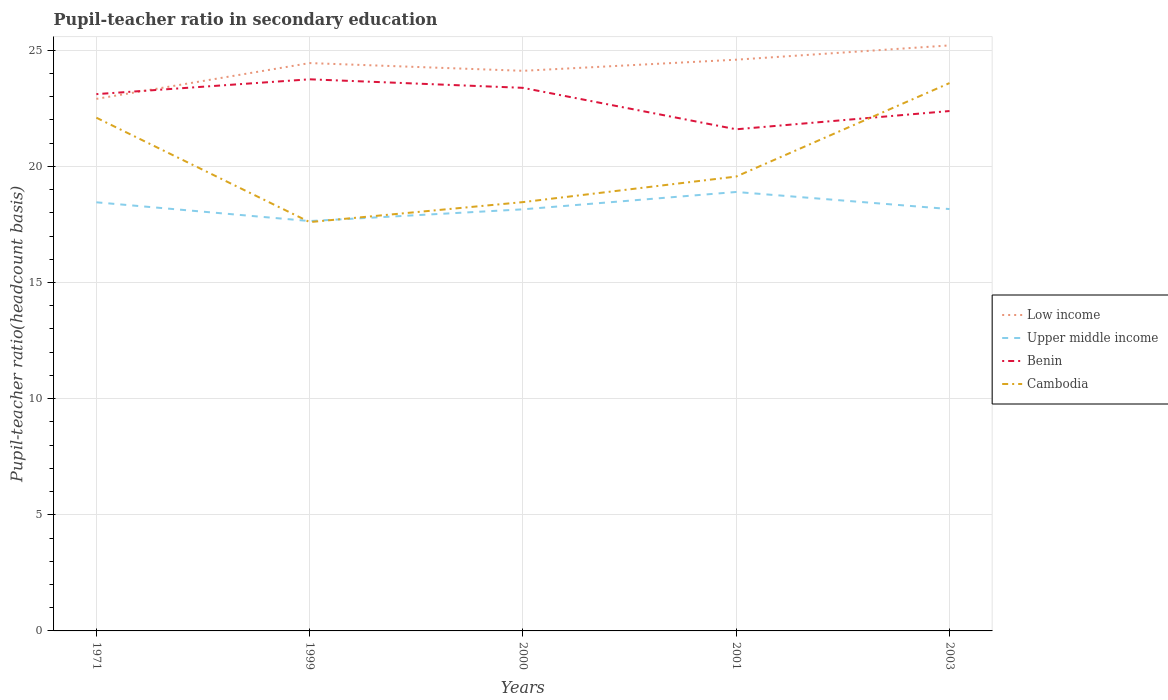How many different coloured lines are there?
Give a very brief answer. 4. Across all years, what is the maximum pupil-teacher ratio in secondary education in Upper middle income?
Provide a short and direct response. 17.65. What is the total pupil-teacher ratio in secondary education in Cambodia in the graph?
Ensure brevity in your answer.  -1.96. What is the difference between the highest and the second highest pupil-teacher ratio in secondary education in Benin?
Ensure brevity in your answer.  2.15. How many lines are there?
Your answer should be compact. 4. How many years are there in the graph?
Your answer should be compact. 5. Are the values on the major ticks of Y-axis written in scientific E-notation?
Offer a very short reply. No. Where does the legend appear in the graph?
Give a very brief answer. Center right. How many legend labels are there?
Keep it short and to the point. 4. How are the legend labels stacked?
Provide a short and direct response. Vertical. What is the title of the graph?
Make the answer very short. Pupil-teacher ratio in secondary education. What is the label or title of the X-axis?
Provide a succinct answer. Years. What is the label or title of the Y-axis?
Ensure brevity in your answer.  Pupil-teacher ratio(headcount basis). What is the Pupil-teacher ratio(headcount basis) in Low income in 1971?
Offer a terse response. 22.91. What is the Pupil-teacher ratio(headcount basis) of Upper middle income in 1971?
Offer a very short reply. 18.46. What is the Pupil-teacher ratio(headcount basis) of Benin in 1971?
Offer a terse response. 23.11. What is the Pupil-teacher ratio(headcount basis) of Cambodia in 1971?
Offer a very short reply. 22.1. What is the Pupil-teacher ratio(headcount basis) of Low income in 1999?
Ensure brevity in your answer.  24.45. What is the Pupil-teacher ratio(headcount basis) of Upper middle income in 1999?
Provide a short and direct response. 17.65. What is the Pupil-teacher ratio(headcount basis) in Benin in 1999?
Your answer should be compact. 23.75. What is the Pupil-teacher ratio(headcount basis) in Cambodia in 1999?
Ensure brevity in your answer.  17.6. What is the Pupil-teacher ratio(headcount basis) of Low income in 2000?
Your response must be concise. 24.12. What is the Pupil-teacher ratio(headcount basis) of Upper middle income in 2000?
Keep it short and to the point. 18.15. What is the Pupil-teacher ratio(headcount basis) in Benin in 2000?
Your response must be concise. 23.38. What is the Pupil-teacher ratio(headcount basis) of Cambodia in 2000?
Offer a terse response. 18.46. What is the Pupil-teacher ratio(headcount basis) of Low income in 2001?
Provide a succinct answer. 24.6. What is the Pupil-teacher ratio(headcount basis) of Upper middle income in 2001?
Offer a terse response. 18.9. What is the Pupil-teacher ratio(headcount basis) of Benin in 2001?
Give a very brief answer. 21.6. What is the Pupil-teacher ratio(headcount basis) in Cambodia in 2001?
Your response must be concise. 19.56. What is the Pupil-teacher ratio(headcount basis) in Low income in 2003?
Offer a terse response. 25.21. What is the Pupil-teacher ratio(headcount basis) in Upper middle income in 2003?
Give a very brief answer. 18.16. What is the Pupil-teacher ratio(headcount basis) in Benin in 2003?
Provide a short and direct response. 22.38. What is the Pupil-teacher ratio(headcount basis) of Cambodia in 2003?
Offer a terse response. 23.59. Across all years, what is the maximum Pupil-teacher ratio(headcount basis) in Low income?
Provide a succinct answer. 25.21. Across all years, what is the maximum Pupil-teacher ratio(headcount basis) in Upper middle income?
Your answer should be very brief. 18.9. Across all years, what is the maximum Pupil-teacher ratio(headcount basis) in Benin?
Offer a very short reply. 23.75. Across all years, what is the maximum Pupil-teacher ratio(headcount basis) in Cambodia?
Keep it short and to the point. 23.59. Across all years, what is the minimum Pupil-teacher ratio(headcount basis) of Low income?
Keep it short and to the point. 22.91. Across all years, what is the minimum Pupil-teacher ratio(headcount basis) in Upper middle income?
Your response must be concise. 17.65. Across all years, what is the minimum Pupil-teacher ratio(headcount basis) of Benin?
Ensure brevity in your answer.  21.6. Across all years, what is the minimum Pupil-teacher ratio(headcount basis) of Cambodia?
Ensure brevity in your answer.  17.6. What is the total Pupil-teacher ratio(headcount basis) in Low income in the graph?
Offer a terse response. 121.28. What is the total Pupil-teacher ratio(headcount basis) in Upper middle income in the graph?
Your answer should be very brief. 91.32. What is the total Pupil-teacher ratio(headcount basis) of Benin in the graph?
Provide a succinct answer. 114.23. What is the total Pupil-teacher ratio(headcount basis) in Cambodia in the graph?
Provide a succinct answer. 101.32. What is the difference between the Pupil-teacher ratio(headcount basis) of Low income in 1971 and that in 1999?
Give a very brief answer. -1.54. What is the difference between the Pupil-teacher ratio(headcount basis) of Upper middle income in 1971 and that in 1999?
Make the answer very short. 0.81. What is the difference between the Pupil-teacher ratio(headcount basis) in Benin in 1971 and that in 1999?
Your response must be concise. -0.64. What is the difference between the Pupil-teacher ratio(headcount basis) in Cambodia in 1971 and that in 1999?
Make the answer very short. 4.49. What is the difference between the Pupil-teacher ratio(headcount basis) in Low income in 1971 and that in 2000?
Give a very brief answer. -1.21. What is the difference between the Pupil-teacher ratio(headcount basis) in Upper middle income in 1971 and that in 2000?
Your response must be concise. 0.3. What is the difference between the Pupil-teacher ratio(headcount basis) in Benin in 1971 and that in 2000?
Make the answer very short. -0.27. What is the difference between the Pupil-teacher ratio(headcount basis) in Cambodia in 1971 and that in 2000?
Your answer should be compact. 3.63. What is the difference between the Pupil-teacher ratio(headcount basis) in Low income in 1971 and that in 2001?
Ensure brevity in your answer.  -1.69. What is the difference between the Pupil-teacher ratio(headcount basis) of Upper middle income in 1971 and that in 2001?
Provide a short and direct response. -0.44. What is the difference between the Pupil-teacher ratio(headcount basis) in Benin in 1971 and that in 2001?
Give a very brief answer. 1.51. What is the difference between the Pupil-teacher ratio(headcount basis) of Cambodia in 1971 and that in 2001?
Your answer should be very brief. 2.53. What is the difference between the Pupil-teacher ratio(headcount basis) of Low income in 1971 and that in 2003?
Keep it short and to the point. -2.3. What is the difference between the Pupil-teacher ratio(headcount basis) of Upper middle income in 1971 and that in 2003?
Ensure brevity in your answer.  0.29. What is the difference between the Pupil-teacher ratio(headcount basis) of Benin in 1971 and that in 2003?
Your response must be concise. 0.73. What is the difference between the Pupil-teacher ratio(headcount basis) of Cambodia in 1971 and that in 2003?
Make the answer very short. -1.49. What is the difference between the Pupil-teacher ratio(headcount basis) of Low income in 1999 and that in 2000?
Your answer should be very brief. 0.33. What is the difference between the Pupil-teacher ratio(headcount basis) in Upper middle income in 1999 and that in 2000?
Offer a very short reply. -0.51. What is the difference between the Pupil-teacher ratio(headcount basis) in Benin in 1999 and that in 2000?
Give a very brief answer. 0.37. What is the difference between the Pupil-teacher ratio(headcount basis) in Cambodia in 1999 and that in 2000?
Your response must be concise. -0.86. What is the difference between the Pupil-teacher ratio(headcount basis) of Low income in 1999 and that in 2001?
Your response must be concise. -0.15. What is the difference between the Pupil-teacher ratio(headcount basis) of Upper middle income in 1999 and that in 2001?
Make the answer very short. -1.25. What is the difference between the Pupil-teacher ratio(headcount basis) in Benin in 1999 and that in 2001?
Your response must be concise. 2.15. What is the difference between the Pupil-teacher ratio(headcount basis) of Cambodia in 1999 and that in 2001?
Offer a very short reply. -1.96. What is the difference between the Pupil-teacher ratio(headcount basis) in Low income in 1999 and that in 2003?
Your response must be concise. -0.76. What is the difference between the Pupil-teacher ratio(headcount basis) in Upper middle income in 1999 and that in 2003?
Ensure brevity in your answer.  -0.52. What is the difference between the Pupil-teacher ratio(headcount basis) in Benin in 1999 and that in 2003?
Ensure brevity in your answer.  1.37. What is the difference between the Pupil-teacher ratio(headcount basis) in Cambodia in 1999 and that in 2003?
Ensure brevity in your answer.  -5.99. What is the difference between the Pupil-teacher ratio(headcount basis) of Low income in 2000 and that in 2001?
Ensure brevity in your answer.  -0.48. What is the difference between the Pupil-teacher ratio(headcount basis) of Upper middle income in 2000 and that in 2001?
Make the answer very short. -0.75. What is the difference between the Pupil-teacher ratio(headcount basis) in Benin in 2000 and that in 2001?
Your answer should be compact. 1.78. What is the difference between the Pupil-teacher ratio(headcount basis) in Cambodia in 2000 and that in 2001?
Provide a succinct answer. -1.1. What is the difference between the Pupil-teacher ratio(headcount basis) in Low income in 2000 and that in 2003?
Offer a very short reply. -1.09. What is the difference between the Pupil-teacher ratio(headcount basis) of Upper middle income in 2000 and that in 2003?
Provide a succinct answer. -0.01. What is the difference between the Pupil-teacher ratio(headcount basis) of Cambodia in 2000 and that in 2003?
Keep it short and to the point. -5.12. What is the difference between the Pupil-teacher ratio(headcount basis) of Low income in 2001 and that in 2003?
Offer a very short reply. -0.61. What is the difference between the Pupil-teacher ratio(headcount basis) in Upper middle income in 2001 and that in 2003?
Your response must be concise. 0.74. What is the difference between the Pupil-teacher ratio(headcount basis) of Benin in 2001 and that in 2003?
Your response must be concise. -0.79. What is the difference between the Pupil-teacher ratio(headcount basis) of Cambodia in 2001 and that in 2003?
Give a very brief answer. -4.02. What is the difference between the Pupil-teacher ratio(headcount basis) in Low income in 1971 and the Pupil-teacher ratio(headcount basis) in Upper middle income in 1999?
Make the answer very short. 5.26. What is the difference between the Pupil-teacher ratio(headcount basis) of Low income in 1971 and the Pupil-teacher ratio(headcount basis) of Benin in 1999?
Provide a succinct answer. -0.84. What is the difference between the Pupil-teacher ratio(headcount basis) of Low income in 1971 and the Pupil-teacher ratio(headcount basis) of Cambodia in 1999?
Ensure brevity in your answer.  5.31. What is the difference between the Pupil-teacher ratio(headcount basis) of Upper middle income in 1971 and the Pupil-teacher ratio(headcount basis) of Benin in 1999?
Offer a very short reply. -5.3. What is the difference between the Pupil-teacher ratio(headcount basis) in Upper middle income in 1971 and the Pupil-teacher ratio(headcount basis) in Cambodia in 1999?
Ensure brevity in your answer.  0.85. What is the difference between the Pupil-teacher ratio(headcount basis) of Benin in 1971 and the Pupil-teacher ratio(headcount basis) of Cambodia in 1999?
Offer a very short reply. 5.51. What is the difference between the Pupil-teacher ratio(headcount basis) of Low income in 1971 and the Pupil-teacher ratio(headcount basis) of Upper middle income in 2000?
Offer a terse response. 4.76. What is the difference between the Pupil-teacher ratio(headcount basis) in Low income in 1971 and the Pupil-teacher ratio(headcount basis) in Benin in 2000?
Offer a very short reply. -0.47. What is the difference between the Pupil-teacher ratio(headcount basis) of Low income in 1971 and the Pupil-teacher ratio(headcount basis) of Cambodia in 2000?
Your response must be concise. 4.45. What is the difference between the Pupil-teacher ratio(headcount basis) in Upper middle income in 1971 and the Pupil-teacher ratio(headcount basis) in Benin in 2000?
Your response must be concise. -4.93. What is the difference between the Pupil-teacher ratio(headcount basis) of Upper middle income in 1971 and the Pupil-teacher ratio(headcount basis) of Cambodia in 2000?
Your response must be concise. -0.01. What is the difference between the Pupil-teacher ratio(headcount basis) of Benin in 1971 and the Pupil-teacher ratio(headcount basis) of Cambodia in 2000?
Keep it short and to the point. 4.65. What is the difference between the Pupil-teacher ratio(headcount basis) in Low income in 1971 and the Pupil-teacher ratio(headcount basis) in Upper middle income in 2001?
Your answer should be compact. 4.01. What is the difference between the Pupil-teacher ratio(headcount basis) in Low income in 1971 and the Pupil-teacher ratio(headcount basis) in Benin in 2001?
Your answer should be very brief. 1.31. What is the difference between the Pupil-teacher ratio(headcount basis) in Low income in 1971 and the Pupil-teacher ratio(headcount basis) in Cambodia in 2001?
Provide a short and direct response. 3.34. What is the difference between the Pupil-teacher ratio(headcount basis) in Upper middle income in 1971 and the Pupil-teacher ratio(headcount basis) in Benin in 2001?
Your response must be concise. -3.14. What is the difference between the Pupil-teacher ratio(headcount basis) of Upper middle income in 1971 and the Pupil-teacher ratio(headcount basis) of Cambodia in 2001?
Give a very brief answer. -1.11. What is the difference between the Pupil-teacher ratio(headcount basis) in Benin in 1971 and the Pupil-teacher ratio(headcount basis) in Cambodia in 2001?
Provide a short and direct response. 3.55. What is the difference between the Pupil-teacher ratio(headcount basis) in Low income in 1971 and the Pupil-teacher ratio(headcount basis) in Upper middle income in 2003?
Offer a terse response. 4.74. What is the difference between the Pupil-teacher ratio(headcount basis) in Low income in 1971 and the Pupil-teacher ratio(headcount basis) in Benin in 2003?
Give a very brief answer. 0.52. What is the difference between the Pupil-teacher ratio(headcount basis) of Low income in 1971 and the Pupil-teacher ratio(headcount basis) of Cambodia in 2003?
Offer a very short reply. -0.68. What is the difference between the Pupil-teacher ratio(headcount basis) of Upper middle income in 1971 and the Pupil-teacher ratio(headcount basis) of Benin in 2003?
Provide a short and direct response. -3.93. What is the difference between the Pupil-teacher ratio(headcount basis) in Upper middle income in 1971 and the Pupil-teacher ratio(headcount basis) in Cambodia in 2003?
Offer a terse response. -5.13. What is the difference between the Pupil-teacher ratio(headcount basis) of Benin in 1971 and the Pupil-teacher ratio(headcount basis) of Cambodia in 2003?
Offer a very short reply. -0.48. What is the difference between the Pupil-teacher ratio(headcount basis) in Low income in 1999 and the Pupil-teacher ratio(headcount basis) in Upper middle income in 2000?
Your answer should be very brief. 6.3. What is the difference between the Pupil-teacher ratio(headcount basis) of Low income in 1999 and the Pupil-teacher ratio(headcount basis) of Benin in 2000?
Give a very brief answer. 1.07. What is the difference between the Pupil-teacher ratio(headcount basis) in Low income in 1999 and the Pupil-teacher ratio(headcount basis) in Cambodia in 2000?
Your answer should be very brief. 5.99. What is the difference between the Pupil-teacher ratio(headcount basis) of Upper middle income in 1999 and the Pupil-teacher ratio(headcount basis) of Benin in 2000?
Offer a terse response. -5.74. What is the difference between the Pupil-teacher ratio(headcount basis) in Upper middle income in 1999 and the Pupil-teacher ratio(headcount basis) in Cambodia in 2000?
Provide a succinct answer. -0.82. What is the difference between the Pupil-teacher ratio(headcount basis) in Benin in 1999 and the Pupil-teacher ratio(headcount basis) in Cambodia in 2000?
Ensure brevity in your answer.  5.29. What is the difference between the Pupil-teacher ratio(headcount basis) of Low income in 1999 and the Pupil-teacher ratio(headcount basis) of Upper middle income in 2001?
Give a very brief answer. 5.55. What is the difference between the Pupil-teacher ratio(headcount basis) in Low income in 1999 and the Pupil-teacher ratio(headcount basis) in Benin in 2001?
Offer a very short reply. 2.85. What is the difference between the Pupil-teacher ratio(headcount basis) of Low income in 1999 and the Pupil-teacher ratio(headcount basis) of Cambodia in 2001?
Offer a very short reply. 4.89. What is the difference between the Pupil-teacher ratio(headcount basis) of Upper middle income in 1999 and the Pupil-teacher ratio(headcount basis) of Benin in 2001?
Offer a terse response. -3.95. What is the difference between the Pupil-teacher ratio(headcount basis) in Upper middle income in 1999 and the Pupil-teacher ratio(headcount basis) in Cambodia in 2001?
Offer a very short reply. -1.92. What is the difference between the Pupil-teacher ratio(headcount basis) of Benin in 1999 and the Pupil-teacher ratio(headcount basis) of Cambodia in 2001?
Keep it short and to the point. 4.19. What is the difference between the Pupil-teacher ratio(headcount basis) in Low income in 1999 and the Pupil-teacher ratio(headcount basis) in Upper middle income in 2003?
Your answer should be very brief. 6.29. What is the difference between the Pupil-teacher ratio(headcount basis) of Low income in 1999 and the Pupil-teacher ratio(headcount basis) of Benin in 2003?
Keep it short and to the point. 2.06. What is the difference between the Pupil-teacher ratio(headcount basis) of Low income in 1999 and the Pupil-teacher ratio(headcount basis) of Cambodia in 2003?
Give a very brief answer. 0.86. What is the difference between the Pupil-teacher ratio(headcount basis) of Upper middle income in 1999 and the Pupil-teacher ratio(headcount basis) of Benin in 2003?
Your answer should be compact. -4.74. What is the difference between the Pupil-teacher ratio(headcount basis) of Upper middle income in 1999 and the Pupil-teacher ratio(headcount basis) of Cambodia in 2003?
Provide a succinct answer. -5.94. What is the difference between the Pupil-teacher ratio(headcount basis) of Benin in 1999 and the Pupil-teacher ratio(headcount basis) of Cambodia in 2003?
Make the answer very short. 0.16. What is the difference between the Pupil-teacher ratio(headcount basis) of Low income in 2000 and the Pupil-teacher ratio(headcount basis) of Upper middle income in 2001?
Provide a short and direct response. 5.22. What is the difference between the Pupil-teacher ratio(headcount basis) of Low income in 2000 and the Pupil-teacher ratio(headcount basis) of Benin in 2001?
Provide a short and direct response. 2.52. What is the difference between the Pupil-teacher ratio(headcount basis) in Low income in 2000 and the Pupil-teacher ratio(headcount basis) in Cambodia in 2001?
Your answer should be compact. 4.55. What is the difference between the Pupil-teacher ratio(headcount basis) of Upper middle income in 2000 and the Pupil-teacher ratio(headcount basis) of Benin in 2001?
Give a very brief answer. -3.45. What is the difference between the Pupil-teacher ratio(headcount basis) in Upper middle income in 2000 and the Pupil-teacher ratio(headcount basis) in Cambodia in 2001?
Provide a short and direct response. -1.41. What is the difference between the Pupil-teacher ratio(headcount basis) of Benin in 2000 and the Pupil-teacher ratio(headcount basis) of Cambodia in 2001?
Your answer should be compact. 3.82. What is the difference between the Pupil-teacher ratio(headcount basis) of Low income in 2000 and the Pupil-teacher ratio(headcount basis) of Upper middle income in 2003?
Ensure brevity in your answer.  5.95. What is the difference between the Pupil-teacher ratio(headcount basis) of Low income in 2000 and the Pupil-teacher ratio(headcount basis) of Benin in 2003?
Your answer should be compact. 1.73. What is the difference between the Pupil-teacher ratio(headcount basis) of Low income in 2000 and the Pupil-teacher ratio(headcount basis) of Cambodia in 2003?
Ensure brevity in your answer.  0.53. What is the difference between the Pupil-teacher ratio(headcount basis) in Upper middle income in 2000 and the Pupil-teacher ratio(headcount basis) in Benin in 2003?
Give a very brief answer. -4.23. What is the difference between the Pupil-teacher ratio(headcount basis) in Upper middle income in 2000 and the Pupil-teacher ratio(headcount basis) in Cambodia in 2003?
Your answer should be very brief. -5.44. What is the difference between the Pupil-teacher ratio(headcount basis) of Benin in 2000 and the Pupil-teacher ratio(headcount basis) of Cambodia in 2003?
Ensure brevity in your answer.  -0.2. What is the difference between the Pupil-teacher ratio(headcount basis) of Low income in 2001 and the Pupil-teacher ratio(headcount basis) of Upper middle income in 2003?
Provide a succinct answer. 6.43. What is the difference between the Pupil-teacher ratio(headcount basis) of Low income in 2001 and the Pupil-teacher ratio(headcount basis) of Benin in 2003?
Make the answer very short. 2.21. What is the difference between the Pupil-teacher ratio(headcount basis) in Low income in 2001 and the Pupil-teacher ratio(headcount basis) in Cambodia in 2003?
Your answer should be compact. 1.01. What is the difference between the Pupil-teacher ratio(headcount basis) in Upper middle income in 2001 and the Pupil-teacher ratio(headcount basis) in Benin in 2003?
Your answer should be compact. -3.49. What is the difference between the Pupil-teacher ratio(headcount basis) of Upper middle income in 2001 and the Pupil-teacher ratio(headcount basis) of Cambodia in 2003?
Keep it short and to the point. -4.69. What is the difference between the Pupil-teacher ratio(headcount basis) in Benin in 2001 and the Pupil-teacher ratio(headcount basis) in Cambodia in 2003?
Provide a succinct answer. -1.99. What is the average Pupil-teacher ratio(headcount basis) of Low income per year?
Keep it short and to the point. 24.26. What is the average Pupil-teacher ratio(headcount basis) in Upper middle income per year?
Ensure brevity in your answer.  18.26. What is the average Pupil-teacher ratio(headcount basis) of Benin per year?
Your response must be concise. 22.85. What is the average Pupil-teacher ratio(headcount basis) of Cambodia per year?
Your answer should be compact. 20.26. In the year 1971, what is the difference between the Pupil-teacher ratio(headcount basis) of Low income and Pupil-teacher ratio(headcount basis) of Upper middle income?
Ensure brevity in your answer.  4.45. In the year 1971, what is the difference between the Pupil-teacher ratio(headcount basis) in Low income and Pupil-teacher ratio(headcount basis) in Benin?
Provide a short and direct response. -0.2. In the year 1971, what is the difference between the Pupil-teacher ratio(headcount basis) of Low income and Pupil-teacher ratio(headcount basis) of Cambodia?
Make the answer very short. 0.81. In the year 1971, what is the difference between the Pupil-teacher ratio(headcount basis) in Upper middle income and Pupil-teacher ratio(headcount basis) in Benin?
Your answer should be compact. -4.66. In the year 1971, what is the difference between the Pupil-teacher ratio(headcount basis) in Upper middle income and Pupil-teacher ratio(headcount basis) in Cambodia?
Your answer should be compact. -3.64. In the year 1971, what is the difference between the Pupil-teacher ratio(headcount basis) of Benin and Pupil-teacher ratio(headcount basis) of Cambodia?
Your answer should be compact. 1.01. In the year 1999, what is the difference between the Pupil-teacher ratio(headcount basis) in Low income and Pupil-teacher ratio(headcount basis) in Upper middle income?
Your answer should be very brief. 6.8. In the year 1999, what is the difference between the Pupil-teacher ratio(headcount basis) of Low income and Pupil-teacher ratio(headcount basis) of Benin?
Offer a very short reply. 0.7. In the year 1999, what is the difference between the Pupil-teacher ratio(headcount basis) in Low income and Pupil-teacher ratio(headcount basis) in Cambodia?
Ensure brevity in your answer.  6.85. In the year 1999, what is the difference between the Pupil-teacher ratio(headcount basis) of Upper middle income and Pupil-teacher ratio(headcount basis) of Benin?
Keep it short and to the point. -6.1. In the year 1999, what is the difference between the Pupil-teacher ratio(headcount basis) in Upper middle income and Pupil-teacher ratio(headcount basis) in Cambodia?
Keep it short and to the point. 0.04. In the year 1999, what is the difference between the Pupil-teacher ratio(headcount basis) in Benin and Pupil-teacher ratio(headcount basis) in Cambodia?
Offer a very short reply. 6.15. In the year 2000, what is the difference between the Pupil-teacher ratio(headcount basis) in Low income and Pupil-teacher ratio(headcount basis) in Upper middle income?
Give a very brief answer. 5.96. In the year 2000, what is the difference between the Pupil-teacher ratio(headcount basis) in Low income and Pupil-teacher ratio(headcount basis) in Benin?
Make the answer very short. 0.73. In the year 2000, what is the difference between the Pupil-teacher ratio(headcount basis) of Low income and Pupil-teacher ratio(headcount basis) of Cambodia?
Make the answer very short. 5.65. In the year 2000, what is the difference between the Pupil-teacher ratio(headcount basis) in Upper middle income and Pupil-teacher ratio(headcount basis) in Benin?
Your response must be concise. -5.23. In the year 2000, what is the difference between the Pupil-teacher ratio(headcount basis) of Upper middle income and Pupil-teacher ratio(headcount basis) of Cambodia?
Your answer should be very brief. -0.31. In the year 2000, what is the difference between the Pupil-teacher ratio(headcount basis) in Benin and Pupil-teacher ratio(headcount basis) in Cambodia?
Offer a terse response. 4.92. In the year 2001, what is the difference between the Pupil-teacher ratio(headcount basis) in Low income and Pupil-teacher ratio(headcount basis) in Upper middle income?
Keep it short and to the point. 5.7. In the year 2001, what is the difference between the Pupil-teacher ratio(headcount basis) in Low income and Pupil-teacher ratio(headcount basis) in Benin?
Offer a very short reply. 3. In the year 2001, what is the difference between the Pupil-teacher ratio(headcount basis) of Low income and Pupil-teacher ratio(headcount basis) of Cambodia?
Keep it short and to the point. 5.03. In the year 2001, what is the difference between the Pupil-teacher ratio(headcount basis) of Upper middle income and Pupil-teacher ratio(headcount basis) of Benin?
Your answer should be compact. -2.7. In the year 2001, what is the difference between the Pupil-teacher ratio(headcount basis) in Upper middle income and Pupil-teacher ratio(headcount basis) in Cambodia?
Ensure brevity in your answer.  -0.66. In the year 2001, what is the difference between the Pupil-teacher ratio(headcount basis) of Benin and Pupil-teacher ratio(headcount basis) of Cambodia?
Your answer should be very brief. 2.03. In the year 2003, what is the difference between the Pupil-teacher ratio(headcount basis) in Low income and Pupil-teacher ratio(headcount basis) in Upper middle income?
Keep it short and to the point. 7.05. In the year 2003, what is the difference between the Pupil-teacher ratio(headcount basis) of Low income and Pupil-teacher ratio(headcount basis) of Benin?
Make the answer very short. 2.83. In the year 2003, what is the difference between the Pupil-teacher ratio(headcount basis) of Low income and Pupil-teacher ratio(headcount basis) of Cambodia?
Provide a short and direct response. 1.62. In the year 2003, what is the difference between the Pupil-teacher ratio(headcount basis) of Upper middle income and Pupil-teacher ratio(headcount basis) of Benin?
Provide a succinct answer. -4.22. In the year 2003, what is the difference between the Pupil-teacher ratio(headcount basis) of Upper middle income and Pupil-teacher ratio(headcount basis) of Cambodia?
Offer a very short reply. -5.42. In the year 2003, what is the difference between the Pupil-teacher ratio(headcount basis) of Benin and Pupil-teacher ratio(headcount basis) of Cambodia?
Ensure brevity in your answer.  -1.2. What is the ratio of the Pupil-teacher ratio(headcount basis) of Low income in 1971 to that in 1999?
Your response must be concise. 0.94. What is the ratio of the Pupil-teacher ratio(headcount basis) of Upper middle income in 1971 to that in 1999?
Ensure brevity in your answer.  1.05. What is the ratio of the Pupil-teacher ratio(headcount basis) of Benin in 1971 to that in 1999?
Your answer should be compact. 0.97. What is the ratio of the Pupil-teacher ratio(headcount basis) of Cambodia in 1971 to that in 1999?
Your answer should be very brief. 1.26. What is the ratio of the Pupil-teacher ratio(headcount basis) in Low income in 1971 to that in 2000?
Your response must be concise. 0.95. What is the ratio of the Pupil-teacher ratio(headcount basis) of Upper middle income in 1971 to that in 2000?
Your response must be concise. 1.02. What is the ratio of the Pupil-teacher ratio(headcount basis) of Benin in 1971 to that in 2000?
Provide a succinct answer. 0.99. What is the ratio of the Pupil-teacher ratio(headcount basis) of Cambodia in 1971 to that in 2000?
Offer a terse response. 1.2. What is the ratio of the Pupil-teacher ratio(headcount basis) in Low income in 1971 to that in 2001?
Give a very brief answer. 0.93. What is the ratio of the Pupil-teacher ratio(headcount basis) of Upper middle income in 1971 to that in 2001?
Provide a succinct answer. 0.98. What is the ratio of the Pupil-teacher ratio(headcount basis) of Benin in 1971 to that in 2001?
Offer a terse response. 1.07. What is the ratio of the Pupil-teacher ratio(headcount basis) in Cambodia in 1971 to that in 2001?
Offer a very short reply. 1.13. What is the ratio of the Pupil-teacher ratio(headcount basis) of Low income in 1971 to that in 2003?
Ensure brevity in your answer.  0.91. What is the ratio of the Pupil-teacher ratio(headcount basis) of Upper middle income in 1971 to that in 2003?
Offer a terse response. 1.02. What is the ratio of the Pupil-teacher ratio(headcount basis) of Benin in 1971 to that in 2003?
Make the answer very short. 1.03. What is the ratio of the Pupil-teacher ratio(headcount basis) in Cambodia in 1971 to that in 2003?
Keep it short and to the point. 0.94. What is the ratio of the Pupil-teacher ratio(headcount basis) of Low income in 1999 to that in 2000?
Your answer should be compact. 1.01. What is the ratio of the Pupil-teacher ratio(headcount basis) in Upper middle income in 1999 to that in 2000?
Provide a succinct answer. 0.97. What is the ratio of the Pupil-teacher ratio(headcount basis) of Benin in 1999 to that in 2000?
Offer a very short reply. 1.02. What is the ratio of the Pupil-teacher ratio(headcount basis) in Cambodia in 1999 to that in 2000?
Ensure brevity in your answer.  0.95. What is the ratio of the Pupil-teacher ratio(headcount basis) of Low income in 1999 to that in 2001?
Make the answer very short. 0.99. What is the ratio of the Pupil-teacher ratio(headcount basis) of Upper middle income in 1999 to that in 2001?
Offer a terse response. 0.93. What is the ratio of the Pupil-teacher ratio(headcount basis) in Benin in 1999 to that in 2001?
Provide a succinct answer. 1.1. What is the ratio of the Pupil-teacher ratio(headcount basis) in Cambodia in 1999 to that in 2001?
Offer a very short reply. 0.9. What is the ratio of the Pupil-teacher ratio(headcount basis) of Low income in 1999 to that in 2003?
Provide a succinct answer. 0.97. What is the ratio of the Pupil-teacher ratio(headcount basis) of Upper middle income in 1999 to that in 2003?
Give a very brief answer. 0.97. What is the ratio of the Pupil-teacher ratio(headcount basis) of Benin in 1999 to that in 2003?
Provide a succinct answer. 1.06. What is the ratio of the Pupil-teacher ratio(headcount basis) in Cambodia in 1999 to that in 2003?
Provide a short and direct response. 0.75. What is the ratio of the Pupil-teacher ratio(headcount basis) in Low income in 2000 to that in 2001?
Your answer should be very brief. 0.98. What is the ratio of the Pupil-teacher ratio(headcount basis) of Upper middle income in 2000 to that in 2001?
Your answer should be compact. 0.96. What is the ratio of the Pupil-teacher ratio(headcount basis) in Benin in 2000 to that in 2001?
Your answer should be very brief. 1.08. What is the ratio of the Pupil-teacher ratio(headcount basis) of Cambodia in 2000 to that in 2001?
Give a very brief answer. 0.94. What is the ratio of the Pupil-teacher ratio(headcount basis) of Low income in 2000 to that in 2003?
Offer a very short reply. 0.96. What is the ratio of the Pupil-teacher ratio(headcount basis) in Benin in 2000 to that in 2003?
Your answer should be very brief. 1.04. What is the ratio of the Pupil-teacher ratio(headcount basis) of Cambodia in 2000 to that in 2003?
Keep it short and to the point. 0.78. What is the ratio of the Pupil-teacher ratio(headcount basis) of Low income in 2001 to that in 2003?
Your response must be concise. 0.98. What is the ratio of the Pupil-teacher ratio(headcount basis) of Upper middle income in 2001 to that in 2003?
Give a very brief answer. 1.04. What is the ratio of the Pupil-teacher ratio(headcount basis) in Benin in 2001 to that in 2003?
Ensure brevity in your answer.  0.96. What is the ratio of the Pupil-teacher ratio(headcount basis) in Cambodia in 2001 to that in 2003?
Provide a succinct answer. 0.83. What is the difference between the highest and the second highest Pupil-teacher ratio(headcount basis) of Low income?
Ensure brevity in your answer.  0.61. What is the difference between the highest and the second highest Pupil-teacher ratio(headcount basis) of Upper middle income?
Your answer should be compact. 0.44. What is the difference between the highest and the second highest Pupil-teacher ratio(headcount basis) of Benin?
Give a very brief answer. 0.37. What is the difference between the highest and the second highest Pupil-teacher ratio(headcount basis) of Cambodia?
Give a very brief answer. 1.49. What is the difference between the highest and the lowest Pupil-teacher ratio(headcount basis) in Low income?
Your response must be concise. 2.3. What is the difference between the highest and the lowest Pupil-teacher ratio(headcount basis) of Upper middle income?
Ensure brevity in your answer.  1.25. What is the difference between the highest and the lowest Pupil-teacher ratio(headcount basis) of Benin?
Offer a very short reply. 2.15. What is the difference between the highest and the lowest Pupil-teacher ratio(headcount basis) in Cambodia?
Make the answer very short. 5.99. 